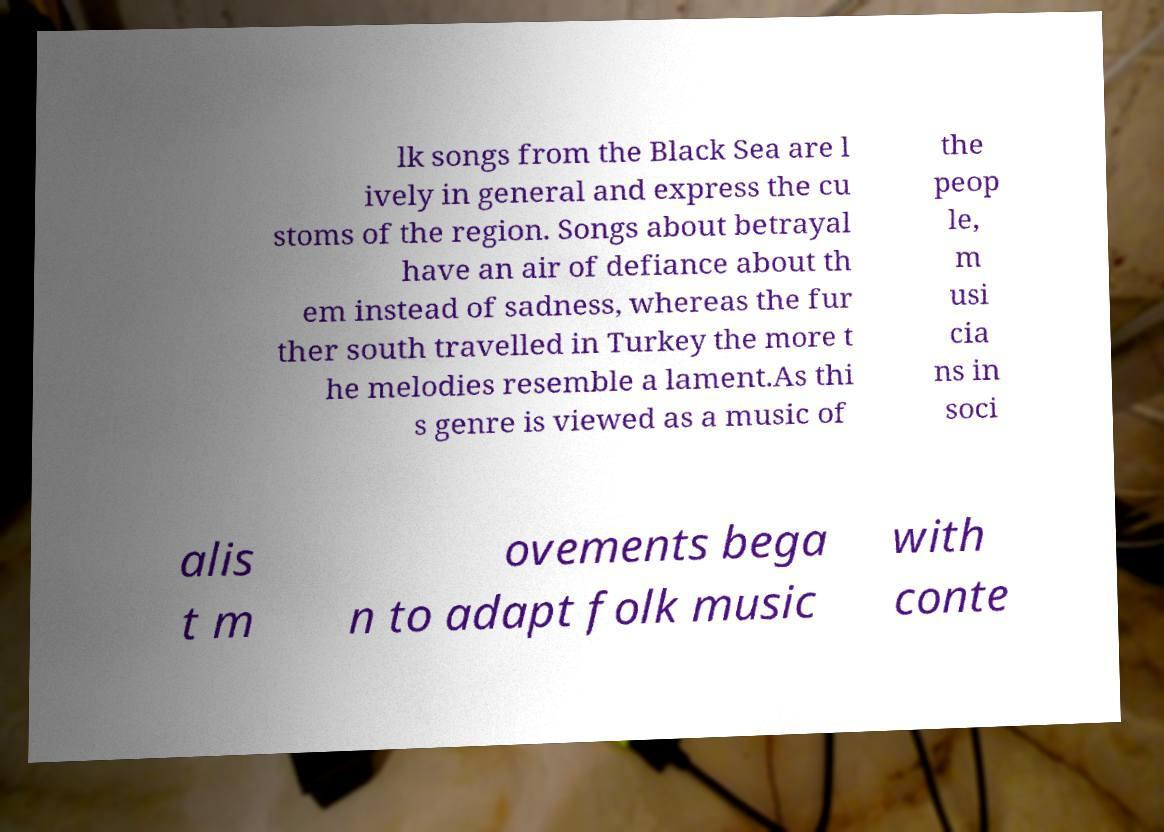Can you accurately transcribe the text from the provided image for me? lk songs from the Black Sea are l ively in general and express the cu stoms of the region. Songs about betrayal have an air of defiance about th em instead of sadness, whereas the fur ther south travelled in Turkey the more t he melodies resemble a lament.As thi s genre is viewed as a music of the peop le, m usi cia ns in soci alis t m ovements bega n to adapt folk music with conte 